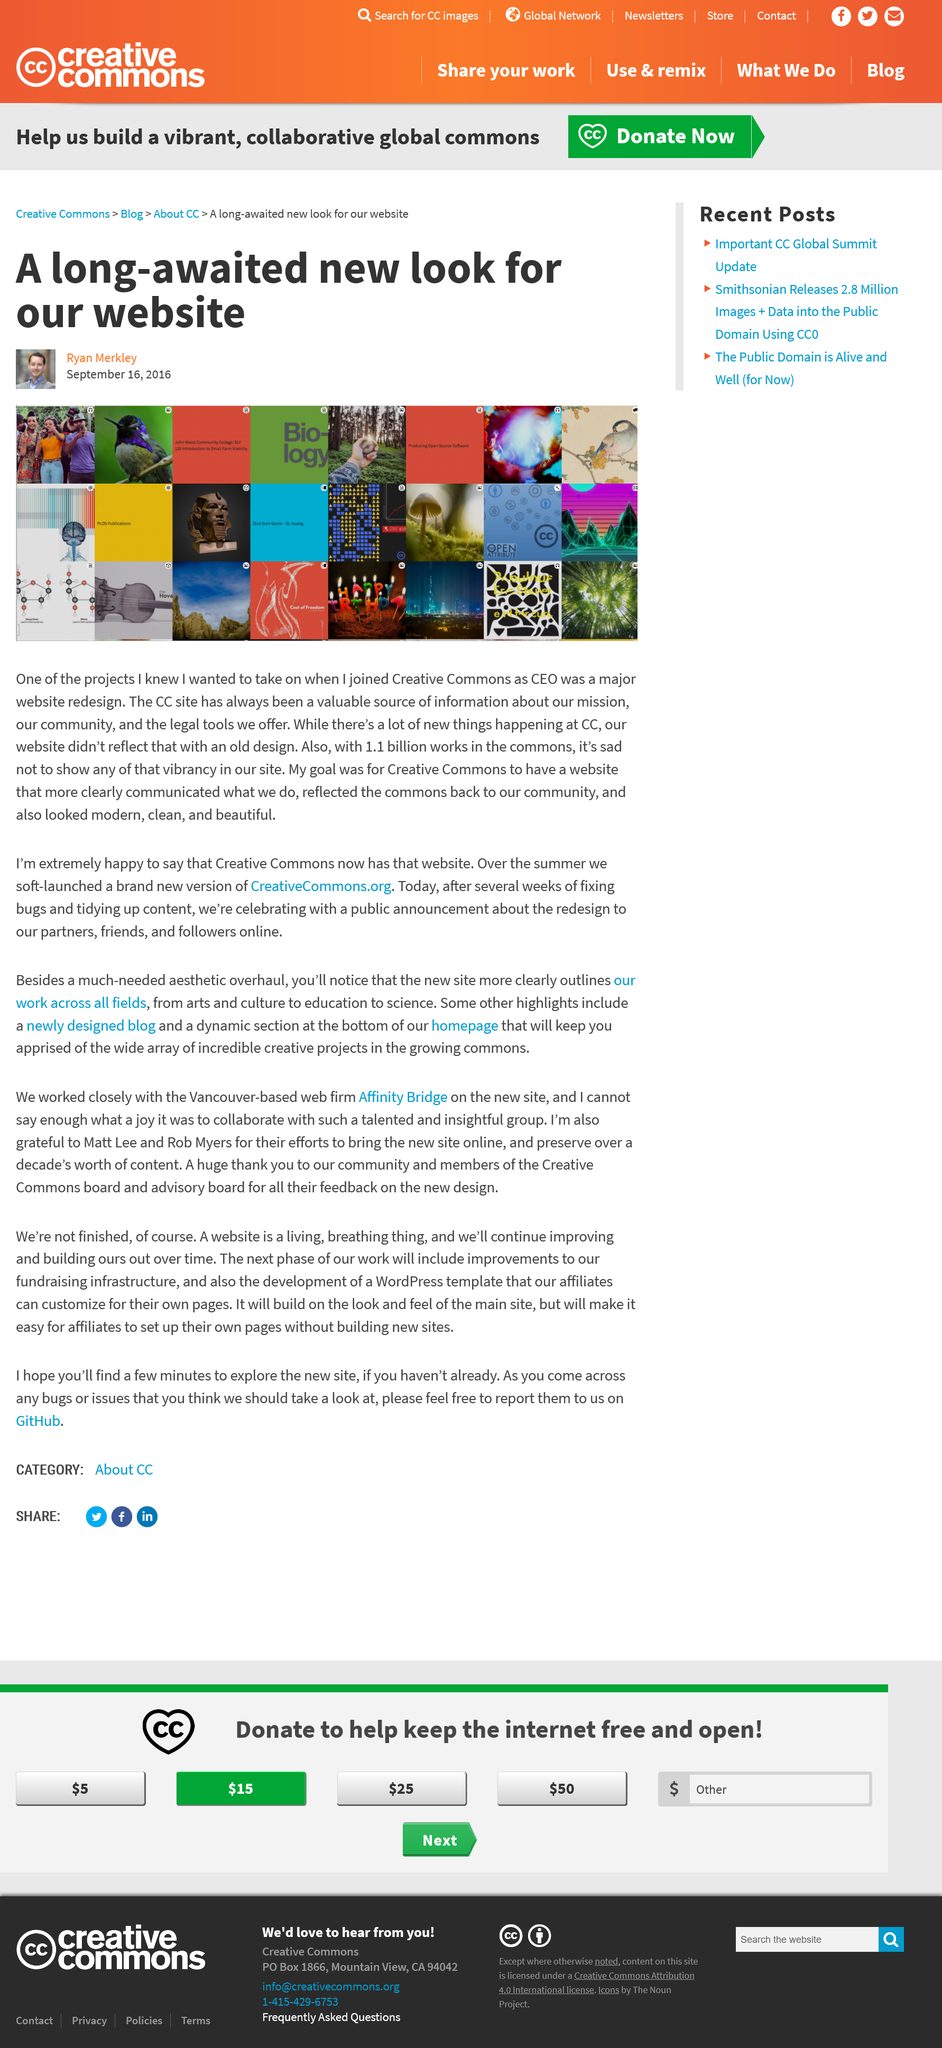Highlight a few significant elements in this photo. It is known that Ryan Merkley is the CEO of CC. The picture depicts the vibrancy of the works displayed in the commons. There are 1.1 billion works in the commons. 